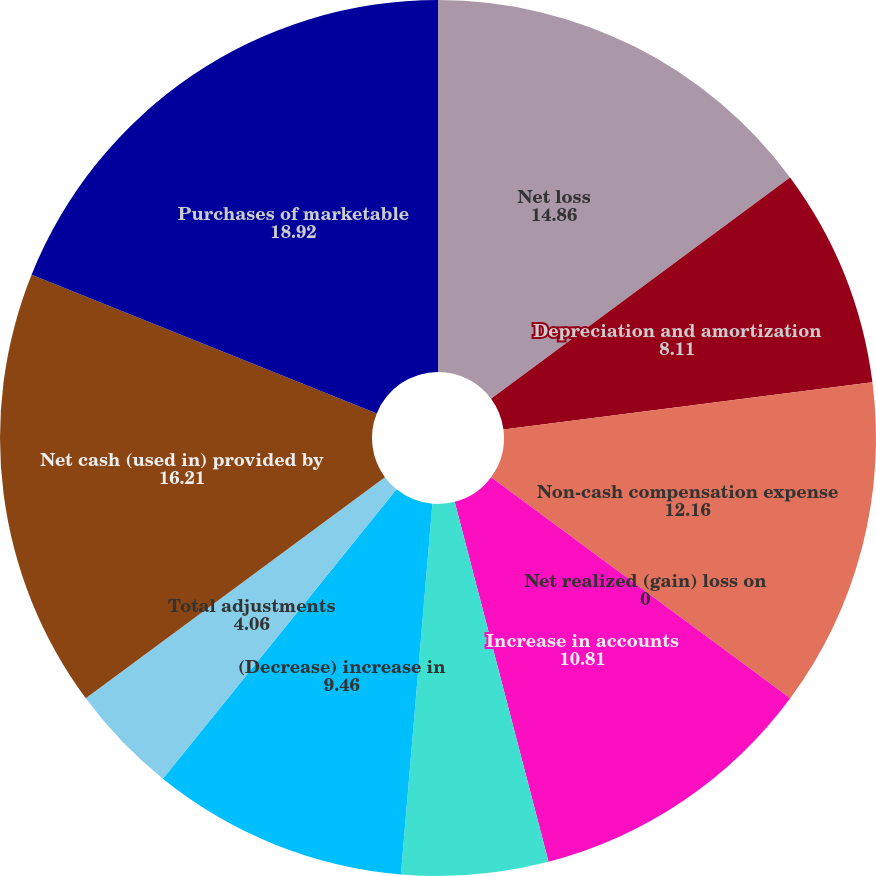Convert chart. <chart><loc_0><loc_0><loc_500><loc_500><pie_chart><fcel>Net loss<fcel>Depreciation and amortization<fcel>Non-cash compensation expense<fcel>Net realized (gain) loss on<fcel>Increase in accounts<fcel>Increase in prepaid expenses<fcel>(Decrease) increase in<fcel>Total adjustments<fcel>Net cash (used in) provided by<fcel>Purchases of marketable<nl><fcel>14.86%<fcel>8.11%<fcel>12.16%<fcel>0.0%<fcel>10.81%<fcel>5.41%<fcel>9.46%<fcel>4.06%<fcel>16.21%<fcel>18.92%<nl></chart> 